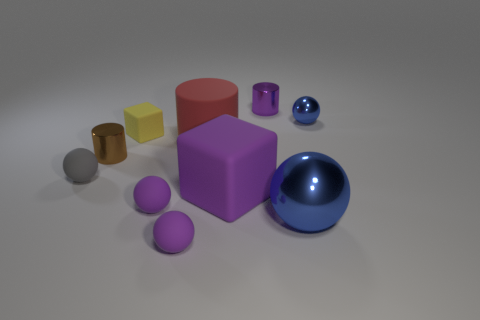Are there any big shiny things behind the brown metallic thing?
Your answer should be very brief. No. How many objects are gray things that are to the left of the purple metal thing or small purple spheres that are in front of the tiny gray ball?
Give a very brief answer. 3. What number of big objects have the same color as the large metal ball?
Offer a very short reply. 0. There is a small shiny object that is the same shape as the big metallic thing; what color is it?
Your answer should be compact. Blue. The purple object that is both right of the red thing and in front of the tiny gray matte object has what shape?
Make the answer very short. Cube. Are there more tiny red metallic cylinders than gray objects?
Give a very brief answer. No. What is the small blue object made of?
Make the answer very short. Metal. Is there any other thing that is the same size as the purple cylinder?
Your answer should be very brief. Yes. What is the size of the red thing that is the same shape as the brown thing?
Offer a very short reply. Large. There is a blue object that is behind the small gray thing; are there any red objects in front of it?
Ensure brevity in your answer.  Yes. 